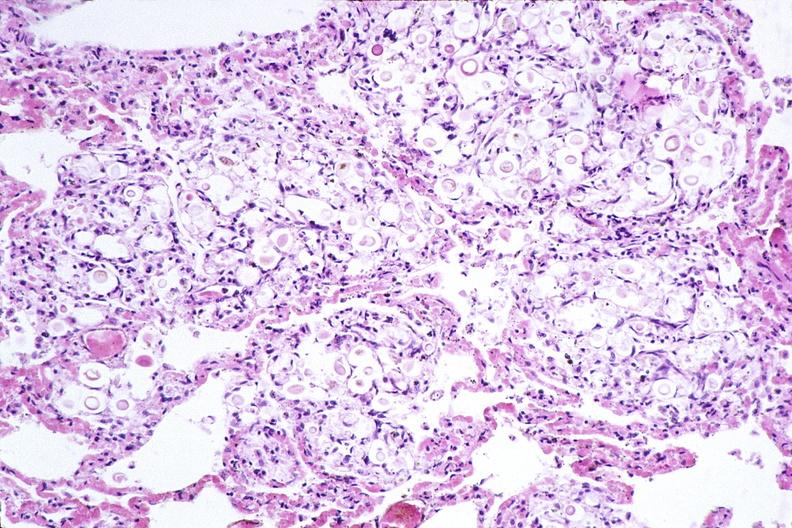what is present?
Answer the question using a single word or phrase. Respiratory 